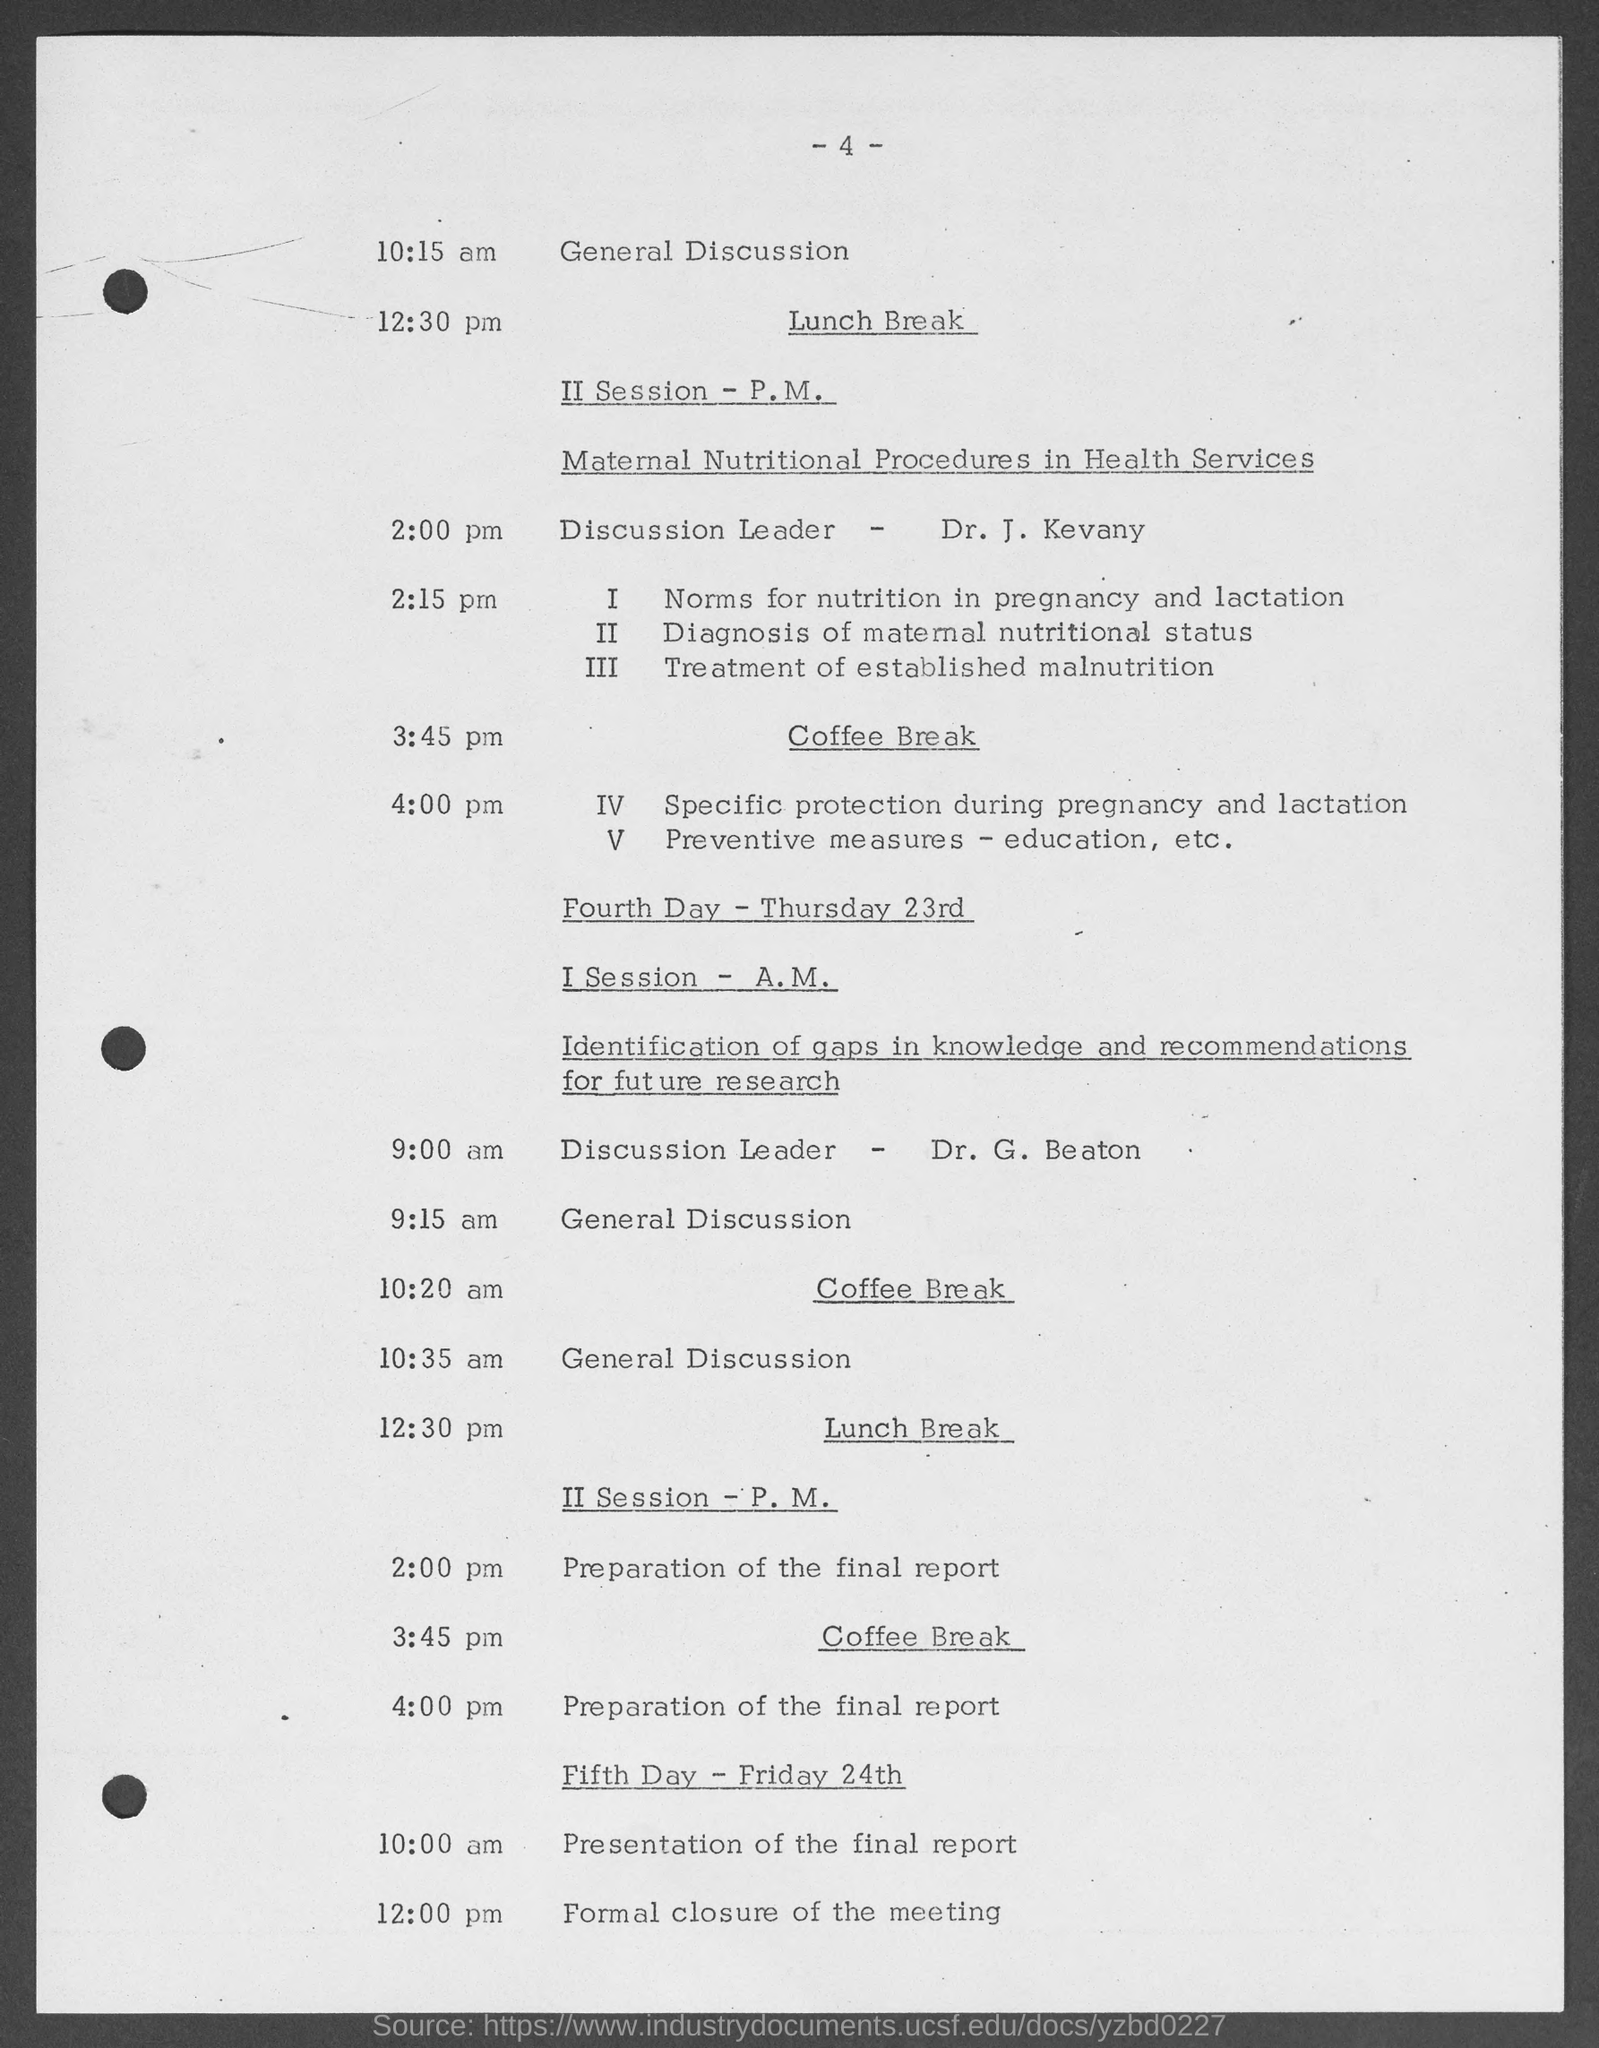Specify some key components in this picture. The page number is 4, as indicated by the numeral -4. The II Session - P.M. will focus on maternal nutritional procedures in health services. The discussion leader for the II Session - P.M. is Dr. J. Kevany. At 10:15 am, there will be a general discussion event. On the fourth day, the I Session - A.M. focused on the identification of gaps in knowledge and the formulation of recommendations for future research. 